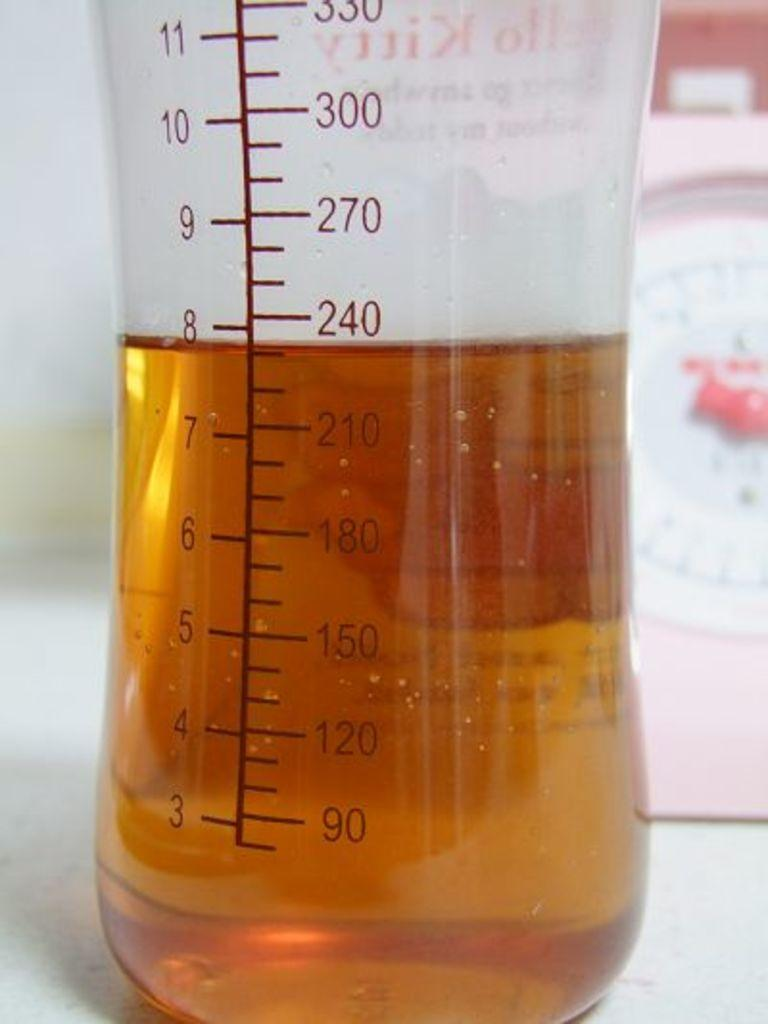Provide a one-sentence caption for the provided image. A baby bottle with eight ounces of juice in it. 